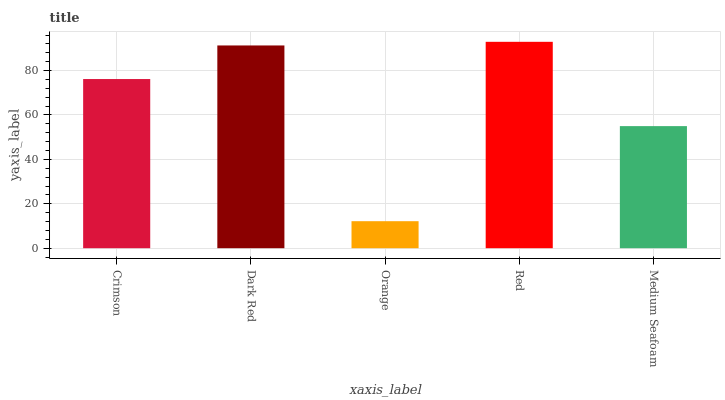Is Orange the minimum?
Answer yes or no. Yes. Is Red the maximum?
Answer yes or no. Yes. Is Dark Red the minimum?
Answer yes or no. No. Is Dark Red the maximum?
Answer yes or no. No. Is Dark Red greater than Crimson?
Answer yes or no. Yes. Is Crimson less than Dark Red?
Answer yes or no. Yes. Is Crimson greater than Dark Red?
Answer yes or no. No. Is Dark Red less than Crimson?
Answer yes or no. No. Is Crimson the high median?
Answer yes or no. Yes. Is Crimson the low median?
Answer yes or no. Yes. Is Red the high median?
Answer yes or no. No. Is Medium Seafoam the low median?
Answer yes or no. No. 